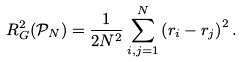<formula> <loc_0><loc_0><loc_500><loc_500>R _ { G } ^ { 2 } ( { \mathcal { P } } _ { N } ) = \frac { 1 } { 2 N ^ { 2 } } \sum _ { i , j = 1 } ^ { N } \left ( { r } _ { i } - { r } _ { j } \right ) ^ { 2 } .</formula> 